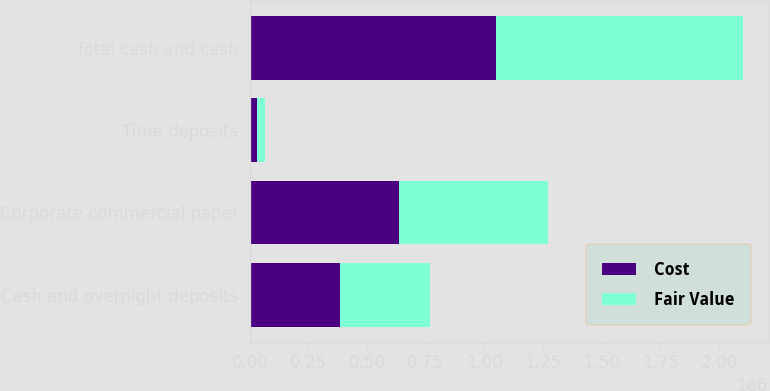Convert chart to OTSL. <chart><loc_0><loc_0><loc_500><loc_500><stacked_bar_chart><ecel><fcel>Cash and overnight deposits<fcel>Corporate commercial paper<fcel>Time deposits<fcel>Total cash and cash<nl><fcel>Cost<fcel>383021<fcel>635345<fcel>32733<fcel>1.0511e+06<nl><fcel>Fair Value<fcel>383021<fcel>635919<fcel>32733<fcel>1.05167e+06<nl></chart> 